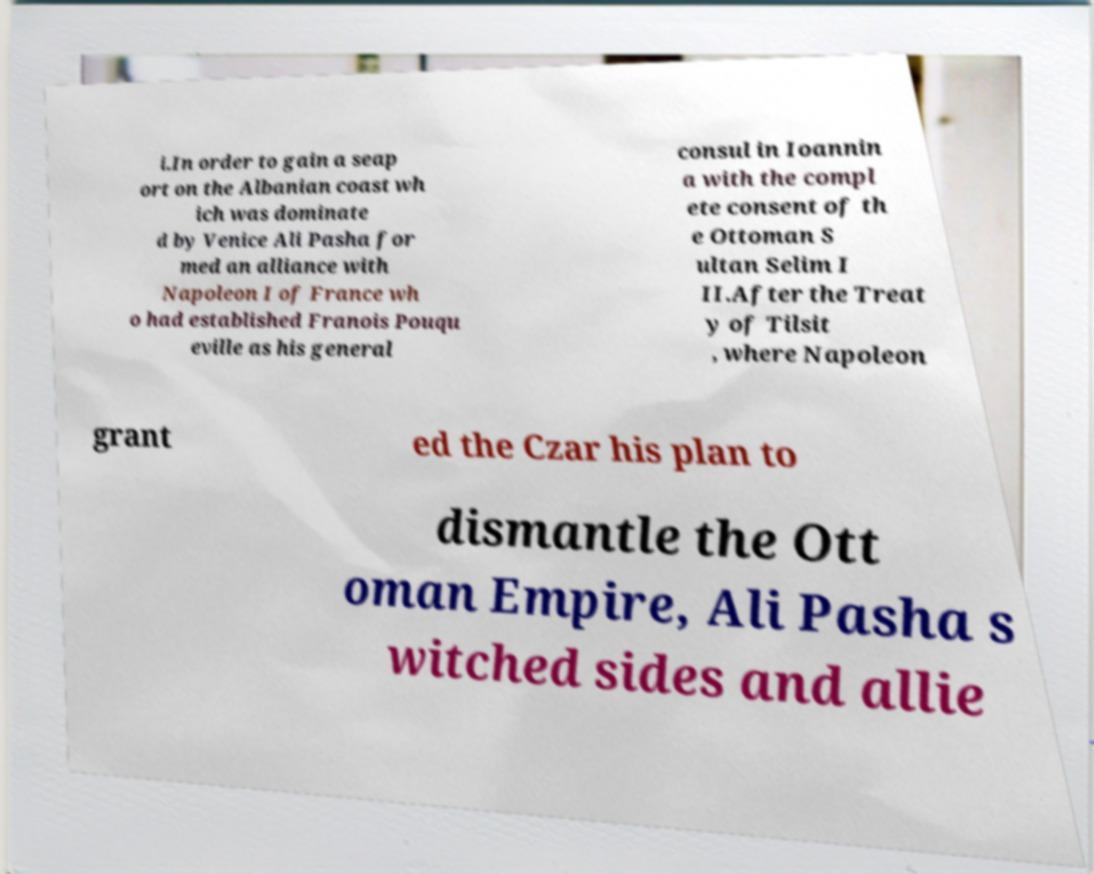Can you accurately transcribe the text from the provided image for me? i.In order to gain a seap ort on the Albanian coast wh ich was dominate d by Venice Ali Pasha for med an alliance with Napoleon I of France wh o had established Franois Pouqu eville as his general consul in Ioannin a with the compl ete consent of th e Ottoman S ultan Selim I II.After the Treat y of Tilsit , where Napoleon grant ed the Czar his plan to dismantle the Ott oman Empire, Ali Pasha s witched sides and allie 